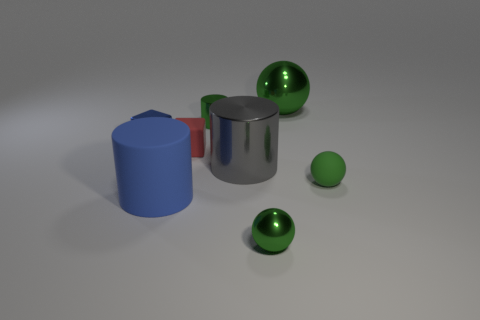There is a cube that is the same color as the matte cylinder; what size is it?
Offer a very short reply. Small. There is a gray cylinder that is made of the same material as the big ball; what is its size?
Make the answer very short. Large. What number of gray objects are blocks or metal cylinders?
Make the answer very short. 1. Is the number of small metal spheres greater than the number of tiny rubber things?
Your response must be concise. No. There is a metallic object that is to the left of the small green cylinder; does it have the same size as the shiny sphere that is to the left of the large sphere?
Your answer should be compact. Yes. There is a rubber object behind the thing to the right of the big shiny ball that is to the right of the tiny red rubber block; what is its color?
Ensure brevity in your answer.  Red. Are there any big cyan things that have the same shape as the big gray object?
Offer a very short reply. No. Is the number of metallic things on the right side of the large metal cylinder greater than the number of large blue spheres?
Give a very brief answer. Yes. How many rubber objects are either large purple cubes or large gray objects?
Your answer should be very brief. 0. What size is the object that is in front of the tiny green matte object and behind the small metal sphere?
Offer a very short reply. Large. 